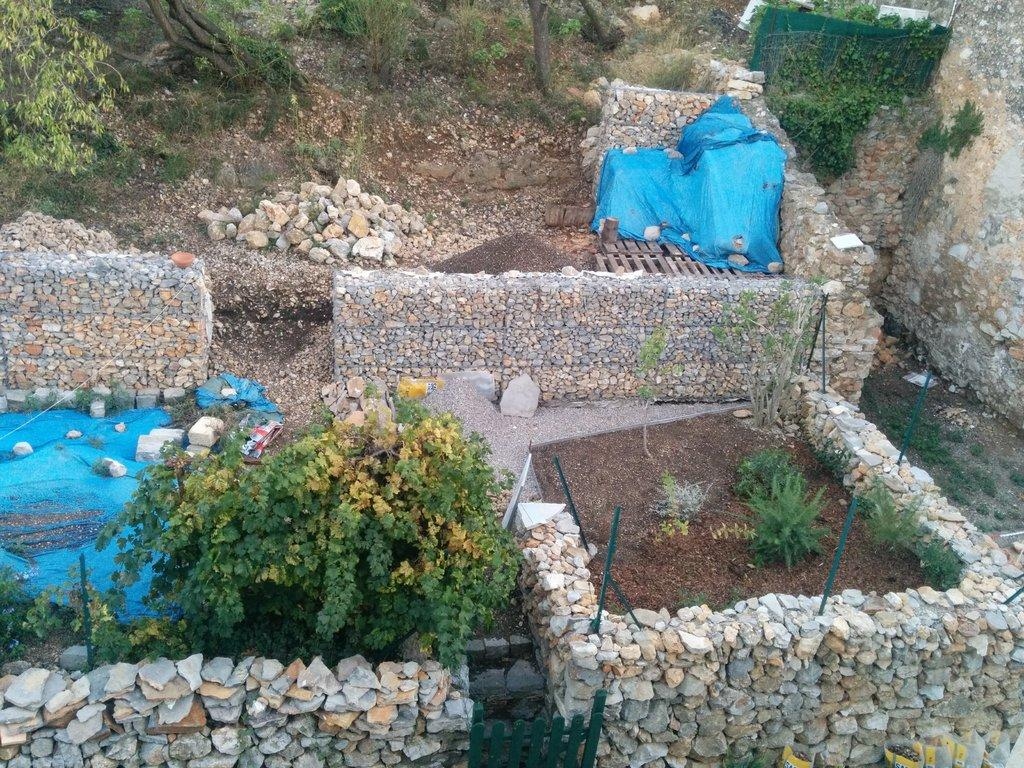What type of environment is depicted in the image? The image is an outside view. What materials are used to construct the walls at the bottom of the image? The walls are constructed with rocks. What types of vegetation can be seen in the image? There are plants and trees in the image. What is present on the ground in the image? There are rocks on the ground in the image. What type of cloud can be seen in the image? There is no cloud visible in the image; it is an outside view with rocks, plants, and trees. What type of breakfast is being served in the image? There is no breakfast or any food present in the image. 